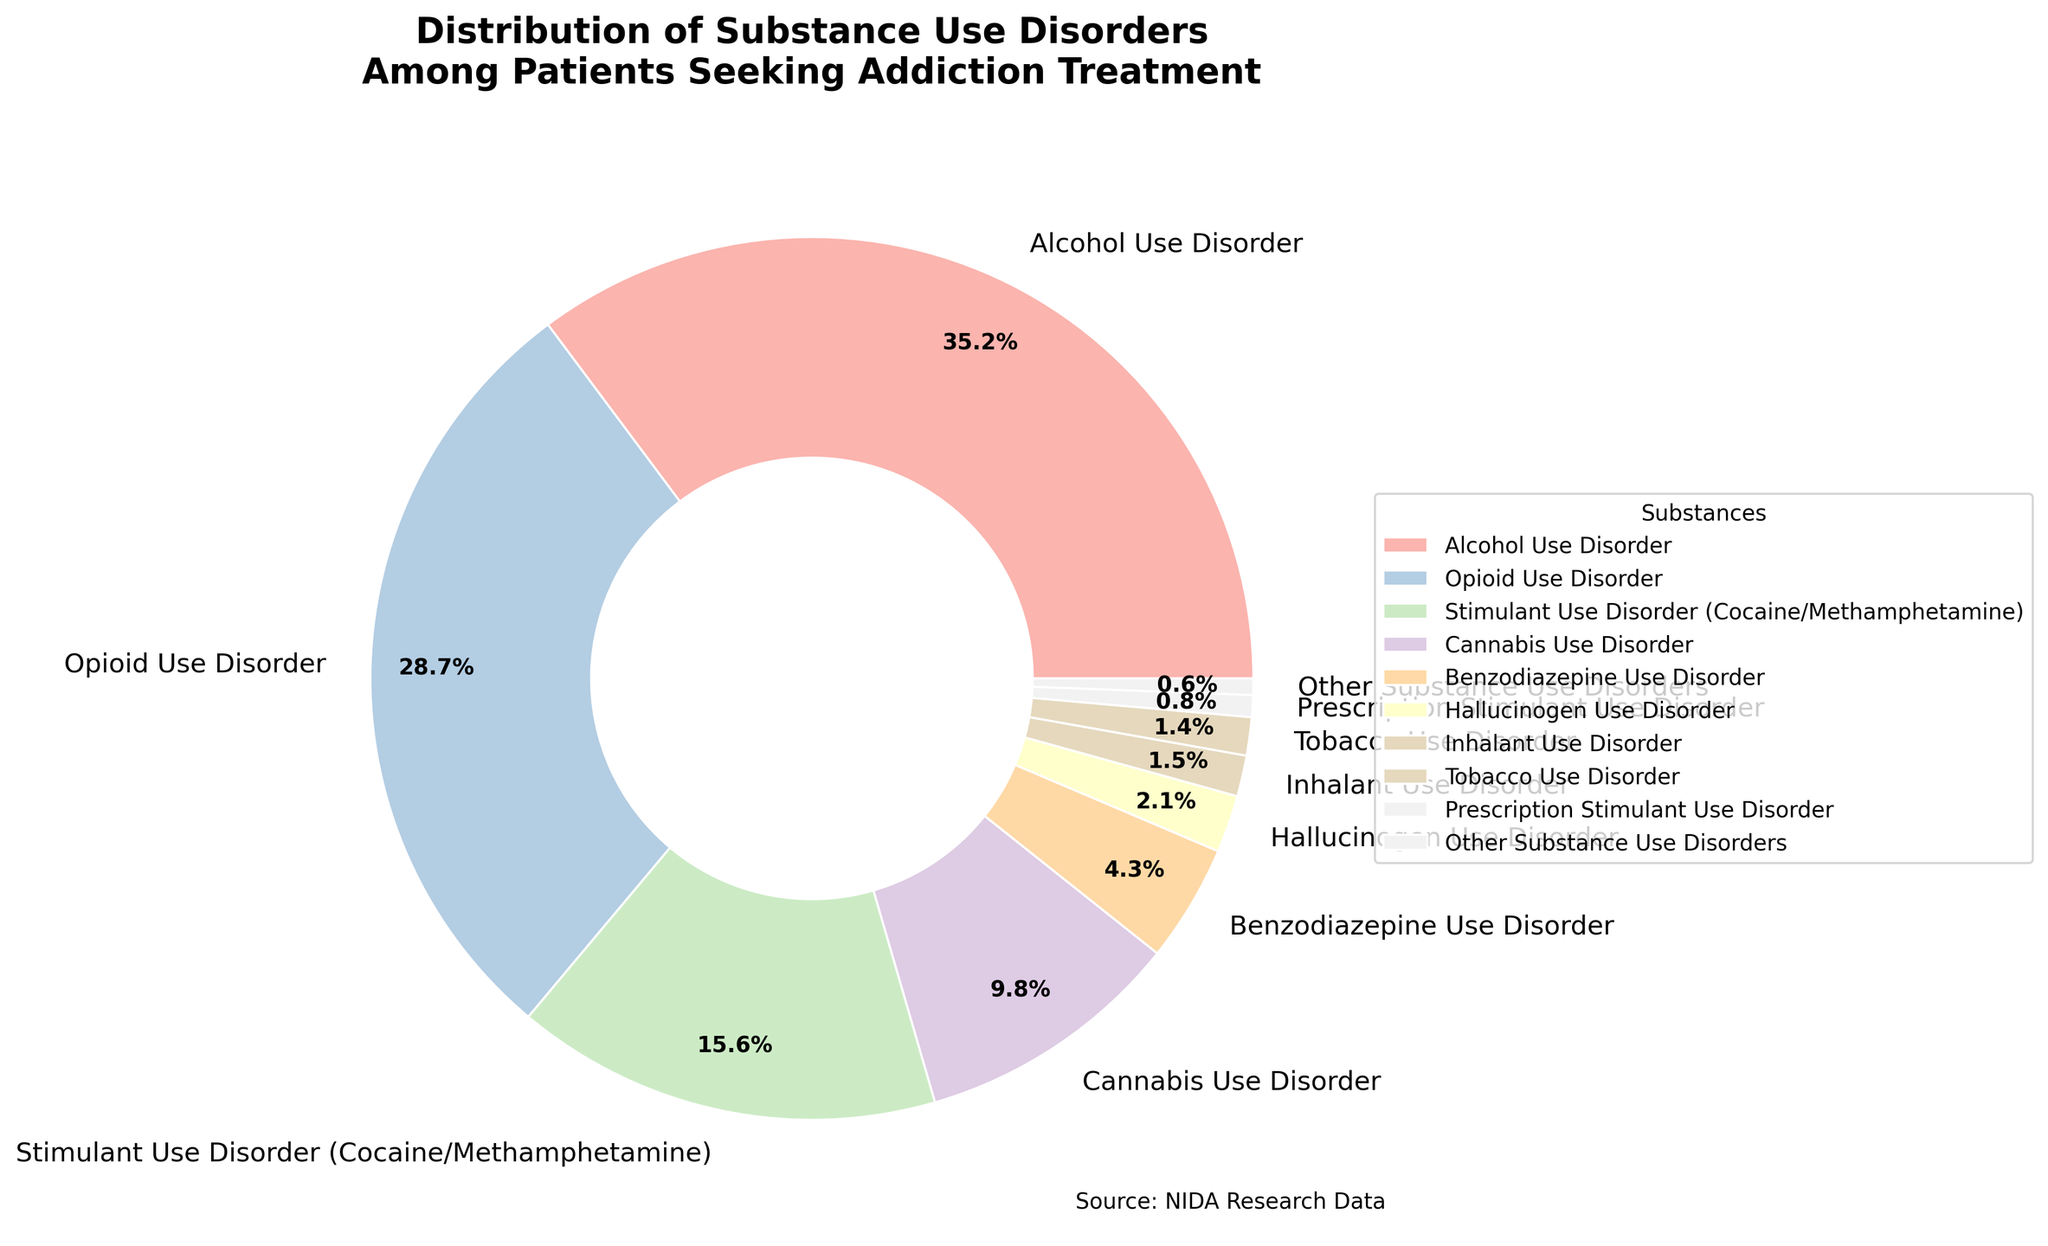Which substance use disorder has the highest percentage? The largest segment in the pie chart is for Alcohol Use Disorder.
Answer: Alcohol Use Disorder Which two substance use disorders have the smallest percentages? The smallest segments in the pie chart are for Prescription Stimulant Use Disorder and Other Substance Use Disorders.
Answer: Prescription Stimulant Use Disorder and Other Substance Use Disorders What is the combined percentage of Cannabis Use Disorder and Benzodiazepine Use Disorder? The percentage for Cannabis Use Disorder is 9.8%, and for Benzodiazepine Use Disorder is 4.3%. Summing these percentages gives 9.8 + 4.3 = 14.1%.
Answer: 14.1% Which substance use disorder has a percentage that is approximately half of Alcohol Use Disorder? Alcohol Use Disorder has 35.2%. Approximately half of this is 17.6%. Stimulant Use Disorder (Cocaine/Methamphetamine) is closest, with 15.6%.
Answer: Stimulant Use Disorder (Cocaine/Methamphetamine) What is the difference in percentage between Opioid Use Disorder and Tobacco Use Disorder? Opioid Use Disorder has 28.7%. Tobacco Use Disorder has 1.4%. The difference is 28.7 - 1.4 = 27.3%.
Answer: 27.3% What percentage of the patients are seeking treatment for a Stimulant Use Disorder (Cocaine/Methamphetamine) or Opioid Use Disorder? The percentage for Stimulant Use Disorder (Cocaine/Methamphetamine) is 15.6% and for Opioid Use Disorder is 28.7%. Summing these gives 15.6 + 28.7 = 44.3%.
Answer: 44.3% Which substance use disorder is represented by the largest colored segment next to Tobacco Use Disorder? The largest colored segment next to Tobacco Use Disorder (1.4%) is Opioid Use Disorder (28.7%).
Answer: Opioid Use Disorder How much more prevalent is Alcohol Use Disorder compared to Hallucinogen Use Disorder? Alcohol Use Disorder is 35.2%, and Hallucinogen Use Disorder is 2.1%. The difference is 35.2 - 2.1 = 33.1%.
Answer: 33.1% Among the different substance use disorders, which ones have a percentage under 2%? The disorders under 2% are Hallucinogen Use Disorder, Inhalant Use Disorder, Tobacco Use Disorder, Prescription Stimulant Use Disorder, and Other Substance Use Disorders.
Answer: Hallucinogen Use Disorder, Inhalant Use Disorder, Tobacco Use Disorder, Prescription Stimulant Use Disorder, and Other Substance Use Disorders 